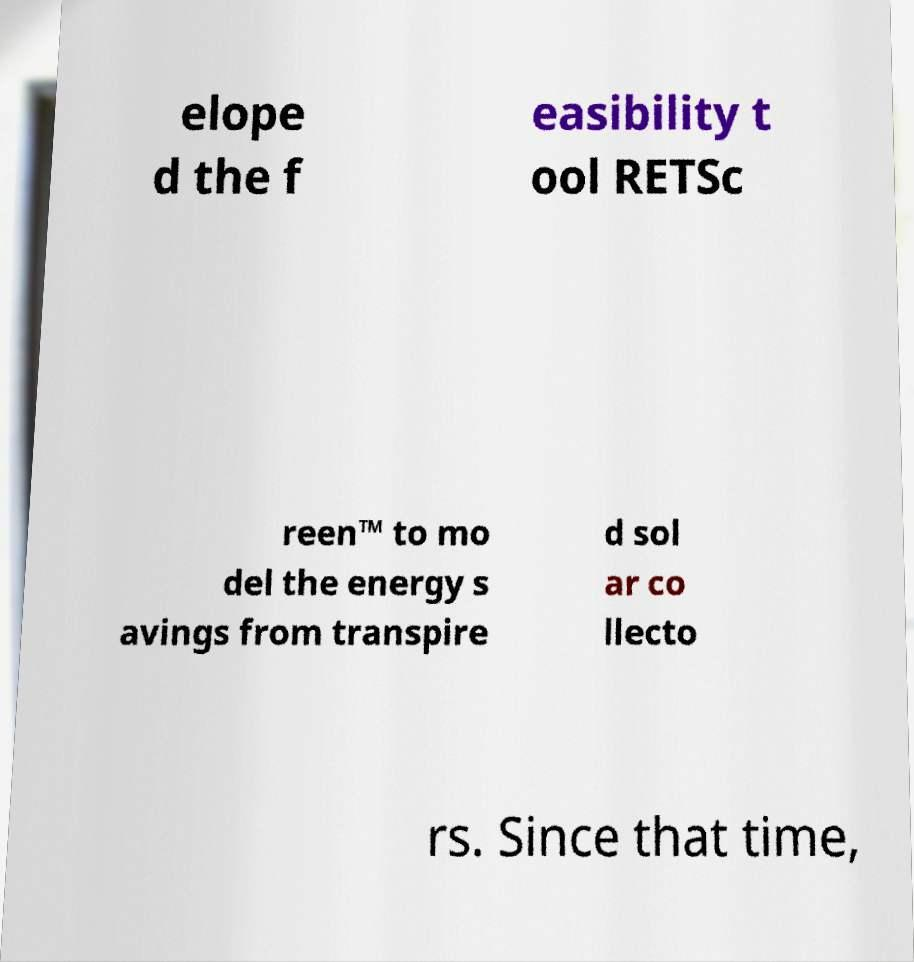There's text embedded in this image that I need extracted. Can you transcribe it verbatim? elope d the f easibility t ool RETSc reen™ to mo del the energy s avings from transpire d sol ar co llecto rs. Since that time, 